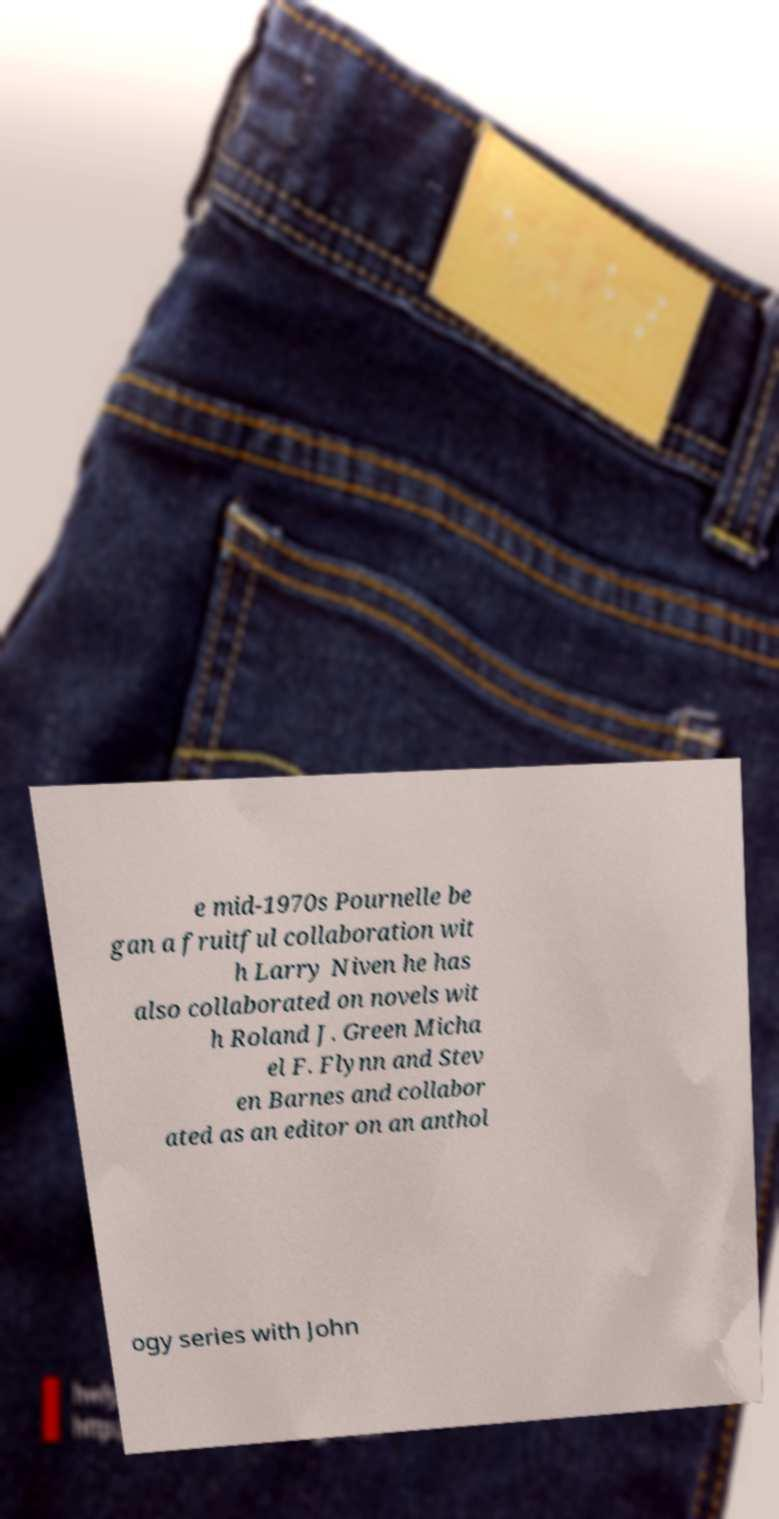There's text embedded in this image that I need extracted. Can you transcribe it verbatim? e mid-1970s Pournelle be gan a fruitful collaboration wit h Larry Niven he has also collaborated on novels wit h Roland J. Green Micha el F. Flynn and Stev en Barnes and collabor ated as an editor on an anthol ogy series with John 